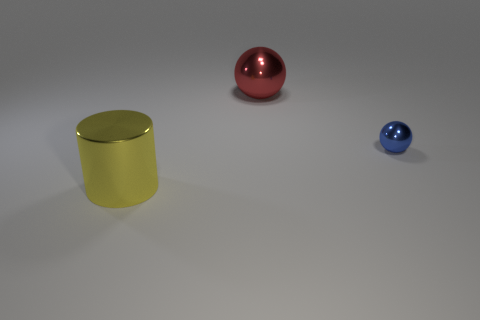Add 3 large gray things. How many objects exist? 6 Subtract all blue spheres. How many spheres are left? 1 Subtract all red metal things. Subtract all big things. How many objects are left? 0 Add 1 large red balls. How many large red balls are left? 2 Add 1 large red spheres. How many large red spheres exist? 2 Subtract 0 green cylinders. How many objects are left? 3 Subtract all cylinders. How many objects are left? 2 Subtract 2 balls. How many balls are left? 0 Subtract all purple spheres. Subtract all gray blocks. How many spheres are left? 2 Subtract all blue cubes. How many blue spheres are left? 1 